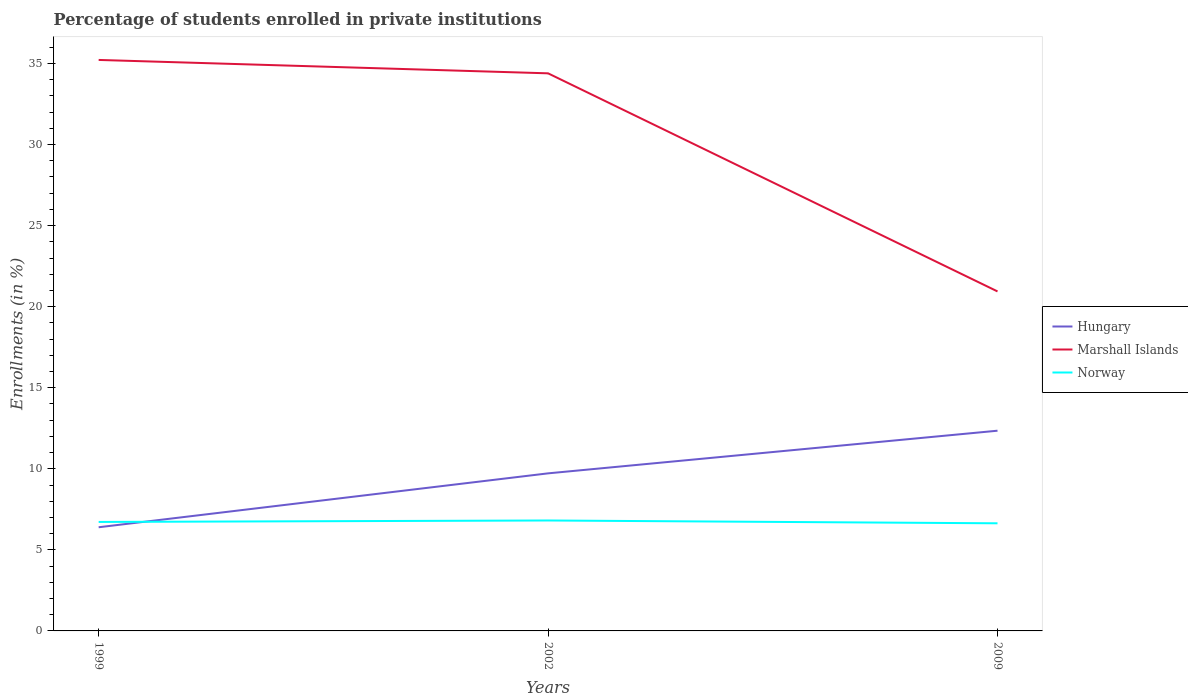Is the number of lines equal to the number of legend labels?
Provide a succinct answer. Yes. Across all years, what is the maximum percentage of trained teachers in Norway?
Ensure brevity in your answer.  6.64. What is the total percentage of trained teachers in Hungary in the graph?
Your response must be concise. -3.33. What is the difference between the highest and the second highest percentage of trained teachers in Marshall Islands?
Ensure brevity in your answer.  14.28. Is the percentage of trained teachers in Marshall Islands strictly greater than the percentage of trained teachers in Norway over the years?
Make the answer very short. No. Does the graph contain grids?
Your answer should be compact. No. Where does the legend appear in the graph?
Make the answer very short. Center right. How many legend labels are there?
Provide a succinct answer. 3. What is the title of the graph?
Offer a terse response. Percentage of students enrolled in private institutions. What is the label or title of the Y-axis?
Your response must be concise. Enrollments (in %). What is the Enrollments (in %) in Hungary in 1999?
Your answer should be very brief. 6.39. What is the Enrollments (in %) of Marshall Islands in 1999?
Your answer should be compact. 35.22. What is the Enrollments (in %) of Norway in 1999?
Give a very brief answer. 6.72. What is the Enrollments (in %) in Hungary in 2002?
Your answer should be compact. 9.72. What is the Enrollments (in %) of Marshall Islands in 2002?
Offer a very short reply. 34.39. What is the Enrollments (in %) in Norway in 2002?
Provide a short and direct response. 6.81. What is the Enrollments (in %) of Hungary in 2009?
Your answer should be very brief. 12.35. What is the Enrollments (in %) in Marshall Islands in 2009?
Provide a short and direct response. 20.94. What is the Enrollments (in %) of Norway in 2009?
Your answer should be very brief. 6.64. Across all years, what is the maximum Enrollments (in %) of Hungary?
Provide a short and direct response. 12.35. Across all years, what is the maximum Enrollments (in %) of Marshall Islands?
Your answer should be compact. 35.22. Across all years, what is the maximum Enrollments (in %) in Norway?
Provide a succinct answer. 6.81. Across all years, what is the minimum Enrollments (in %) of Hungary?
Ensure brevity in your answer.  6.39. Across all years, what is the minimum Enrollments (in %) of Marshall Islands?
Your answer should be compact. 20.94. Across all years, what is the minimum Enrollments (in %) in Norway?
Provide a short and direct response. 6.64. What is the total Enrollments (in %) of Hungary in the graph?
Your answer should be compact. 28.46. What is the total Enrollments (in %) of Marshall Islands in the graph?
Keep it short and to the point. 90.55. What is the total Enrollments (in %) of Norway in the graph?
Offer a terse response. 20.17. What is the difference between the Enrollments (in %) in Hungary in 1999 and that in 2002?
Make the answer very short. -3.33. What is the difference between the Enrollments (in %) of Marshall Islands in 1999 and that in 2002?
Keep it short and to the point. 0.83. What is the difference between the Enrollments (in %) in Norway in 1999 and that in 2002?
Your response must be concise. -0.09. What is the difference between the Enrollments (in %) in Hungary in 1999 and that in 2009?
Make the answer very short. -5.96. What is the difference between the Enrollments (in %) in Marshall Islands in 1999 and that in 2009?
Provide a succinct answer. 14.28. What is the difference between the Enrollments (in %) of Norway in 1999 and that in 2009?
Offer a terse response. 0.08. What is the difference between the Enrollments (in %) in Hungary in 2002 and that in 2009?
Give a very brief answer. -2.63. What is the difference between the Enrollments (in %) of Marshall Islands in 2002 and that in 2009?
Ensure brevity in your answer.  13.45. What is the difference between the Enrollments (in %) of Norway in 2002 and that in 2009?
Offer a very short reply. 0.17. What is the difference between the Enrollments (in %) in Hungary in 1999 and the Enrollments (in %) in Marshall Islands in 2002?
Give a very brief answer. -28. What is the difference between the Enrollments (in %) of Hungary in 1999 and the Enrollments (in %) of Norway in 2002?
Your answer should be very brief. -0.42. What is the difference between the Enrollments (in %) in Marshall Islands in 1999 and the Enrollments (in %) in Norway in 2002?
Keep it short and to the point. 28.41. What is the difference between the Enrollments (in %) of Hungary in 1999 and the Enrollments (in %) of Marshall Islands in 2009?
Provide a short and direct response. -14.55. What is the difference between the Enrollments (in %) in Hungary in 1999 and the Enrollments (in %) in Norway in 2009?
Your response must be concise. -0.24. What is the difference between the Enrollments (in %) of Marshall Islands in 1999 and the Enrollments (in %) of Norway in 2009?
Keep it short and to the point. 28.58. What is the difference between the Enrollments (in %) in Hungary in 2002 and the Enrollments (in %) in Marshall Islands in 2009?
Your response must be concise. -11.22. What is the difference between the Enrollments (in %) of Hungary in 2002 and the Enrollments (in %) of Norway in 2009?
Make the answer very short. 3.08. What is the difference between the Enrollments (in %) in Marshall Islands in 2002 and the Enrollments (in %) in Norway in 2009?
Give a very brief answer. 27.75. What is the average Enrollments (in %) of Hungary per year?
Provide a succinct answer. 9.49. What is the average Enrollments (in %) in Marshall Islands per year?
Your answer should be compact. 30.18. What is the average Enrollments (in %) in Norway per year?
Make the answer very short. 6.72. In the year 1999, what is the difference between the Enrollments (in %) in Hungary and Enrollments (in %) in Marshall Islands?
Keep it short and to the point. -28.82. In the year 1999, what is the difference between the Enrollments (in %) in Hungary and Enrollments (in %) in Norway?
Your answer should be very brief. -0.33. In the year 1999, what is the difference between the Enrollments (in %) in Marshall Islands and Enrollments (in %) in Norway?
Offer a terse response. 28.5. In the year 2002, what is the difference between the Enrollments (in %) in Hungary and Enrollments (in %) in Marshall Islands?
Give a very brief answer. -24.67. In the year 2002, what is the difference between the Enrollments (in %) of Hungary and Enrollments (in %) of Norway?
Ensure brevity in your answer.  2.91. In the year 2002, what is the difference between the Enrollments (in %) in Marshall Islands and Enrollments (in %) in Norway?
Give a very brief answer. 27.58. In the year 2009, what is the difference between the Enrollments (in %) of Hungary and Enrollments (in %) of Marshall Islands?
Keep it short and to the point. -8.59. In the year 2009, what is the difference between the Enrollments (in %) in Hungary and Enrollments (in %) in Norway?
Your answer should be compact. 5.71. In the year 2009, what is the difference between the Enrollments (in %) of Marshall Islands and Enrollments (in %) of Norway?
Offer a terse response. 14.3. What is the ratio of the Enrollments (in %) of Hungary in 1999 to that in 2002?
Provide a succinct answer. 0.66. What is the ratio of the Enrollments (in %) of Marshall Islands in 1999 to that in 2002?
Ensure brevity in your answer.  1.02. What is the ratio of the Enrollments (in %) of Norway in 1999 to that in 2002?
Offer a terse response. 0.99. What is the ratio of the Enrollments (in %) in Hungary in 1999 to that in 2009?
Offer a very short reply. 0.52. What is the ratio of the Enrollments (in %) in Marshall Islands in 1999 to that in 2009?
Ensure brevity in your answer.  1.68. What is the ratio of the Enrollments (in %) in Norway in 1999 to that in 2009?
Give a very brief answer. 1.01. What is the ratio of the Enrollments (in %) in Hungary in 2002 to that in 2009?
Provide a succinct answer. 0.79. What is the ratio of the Enrollments (in %) of Marshall Islands in 2002 to that in 2009?
Give a very brief answer. 1.64. What is the ratio of the Enrollments (in %) of Norway in 2002 to that in 2009?
Your answer should be very brief. 1.03. What is the difference between the highest and the second highest Enrollments (in %) in Hungary?
Your answer should be compact. 2.63. What is the difference between the highest and the second highest Enrollments (in %) of Marshall Islands?
Give a very brief answer. 0.83. What is the difference between the highest and the second highest Enrollments (in %) of Norway?
Provide a succinct answer. 0.09. What is the difference between the highest and the lowest Enrollments (in %) of Hungary?
Your answer should be compact. 5.96. What is the difference between the highest and the lowest Enrollments (in %) in Marshall Islands?
Provide a succinct answer. 14.28. What is the difference between the highest and the lowest Enrollments (in %) in Norway?
Keep it short and to the point. 0.17. 